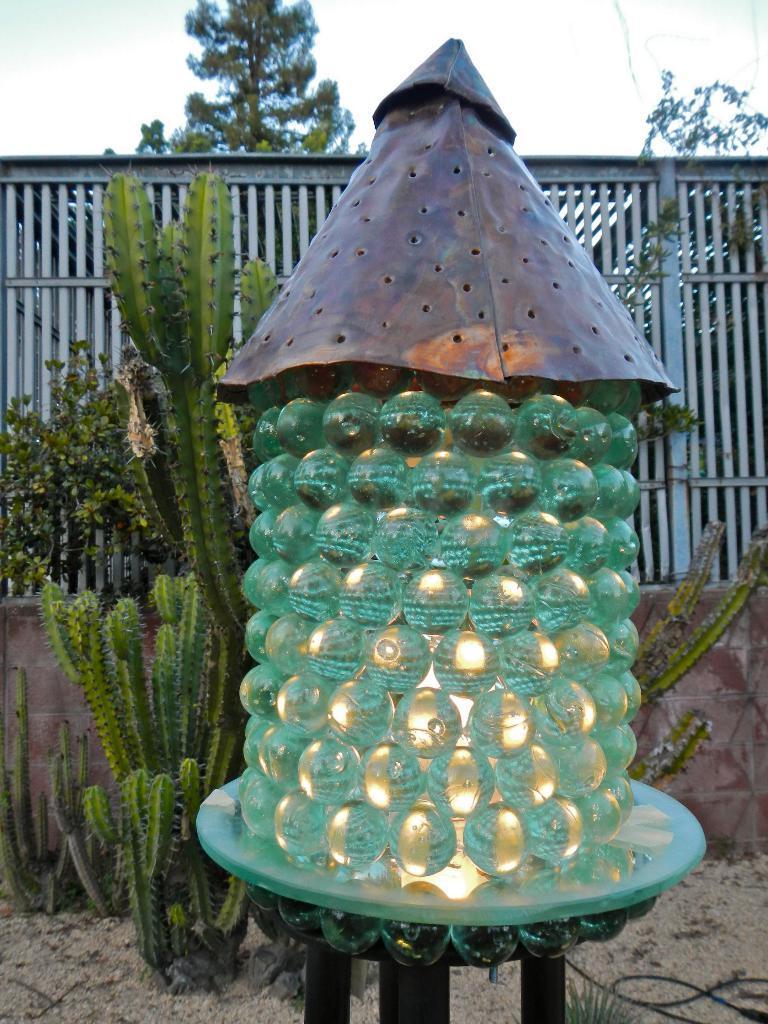Describe this image in one or two sentences. In this image I can see few green color marbles on the stand and light inside. Back I can see plants,trees and railing. The sky is in blue and white color. 